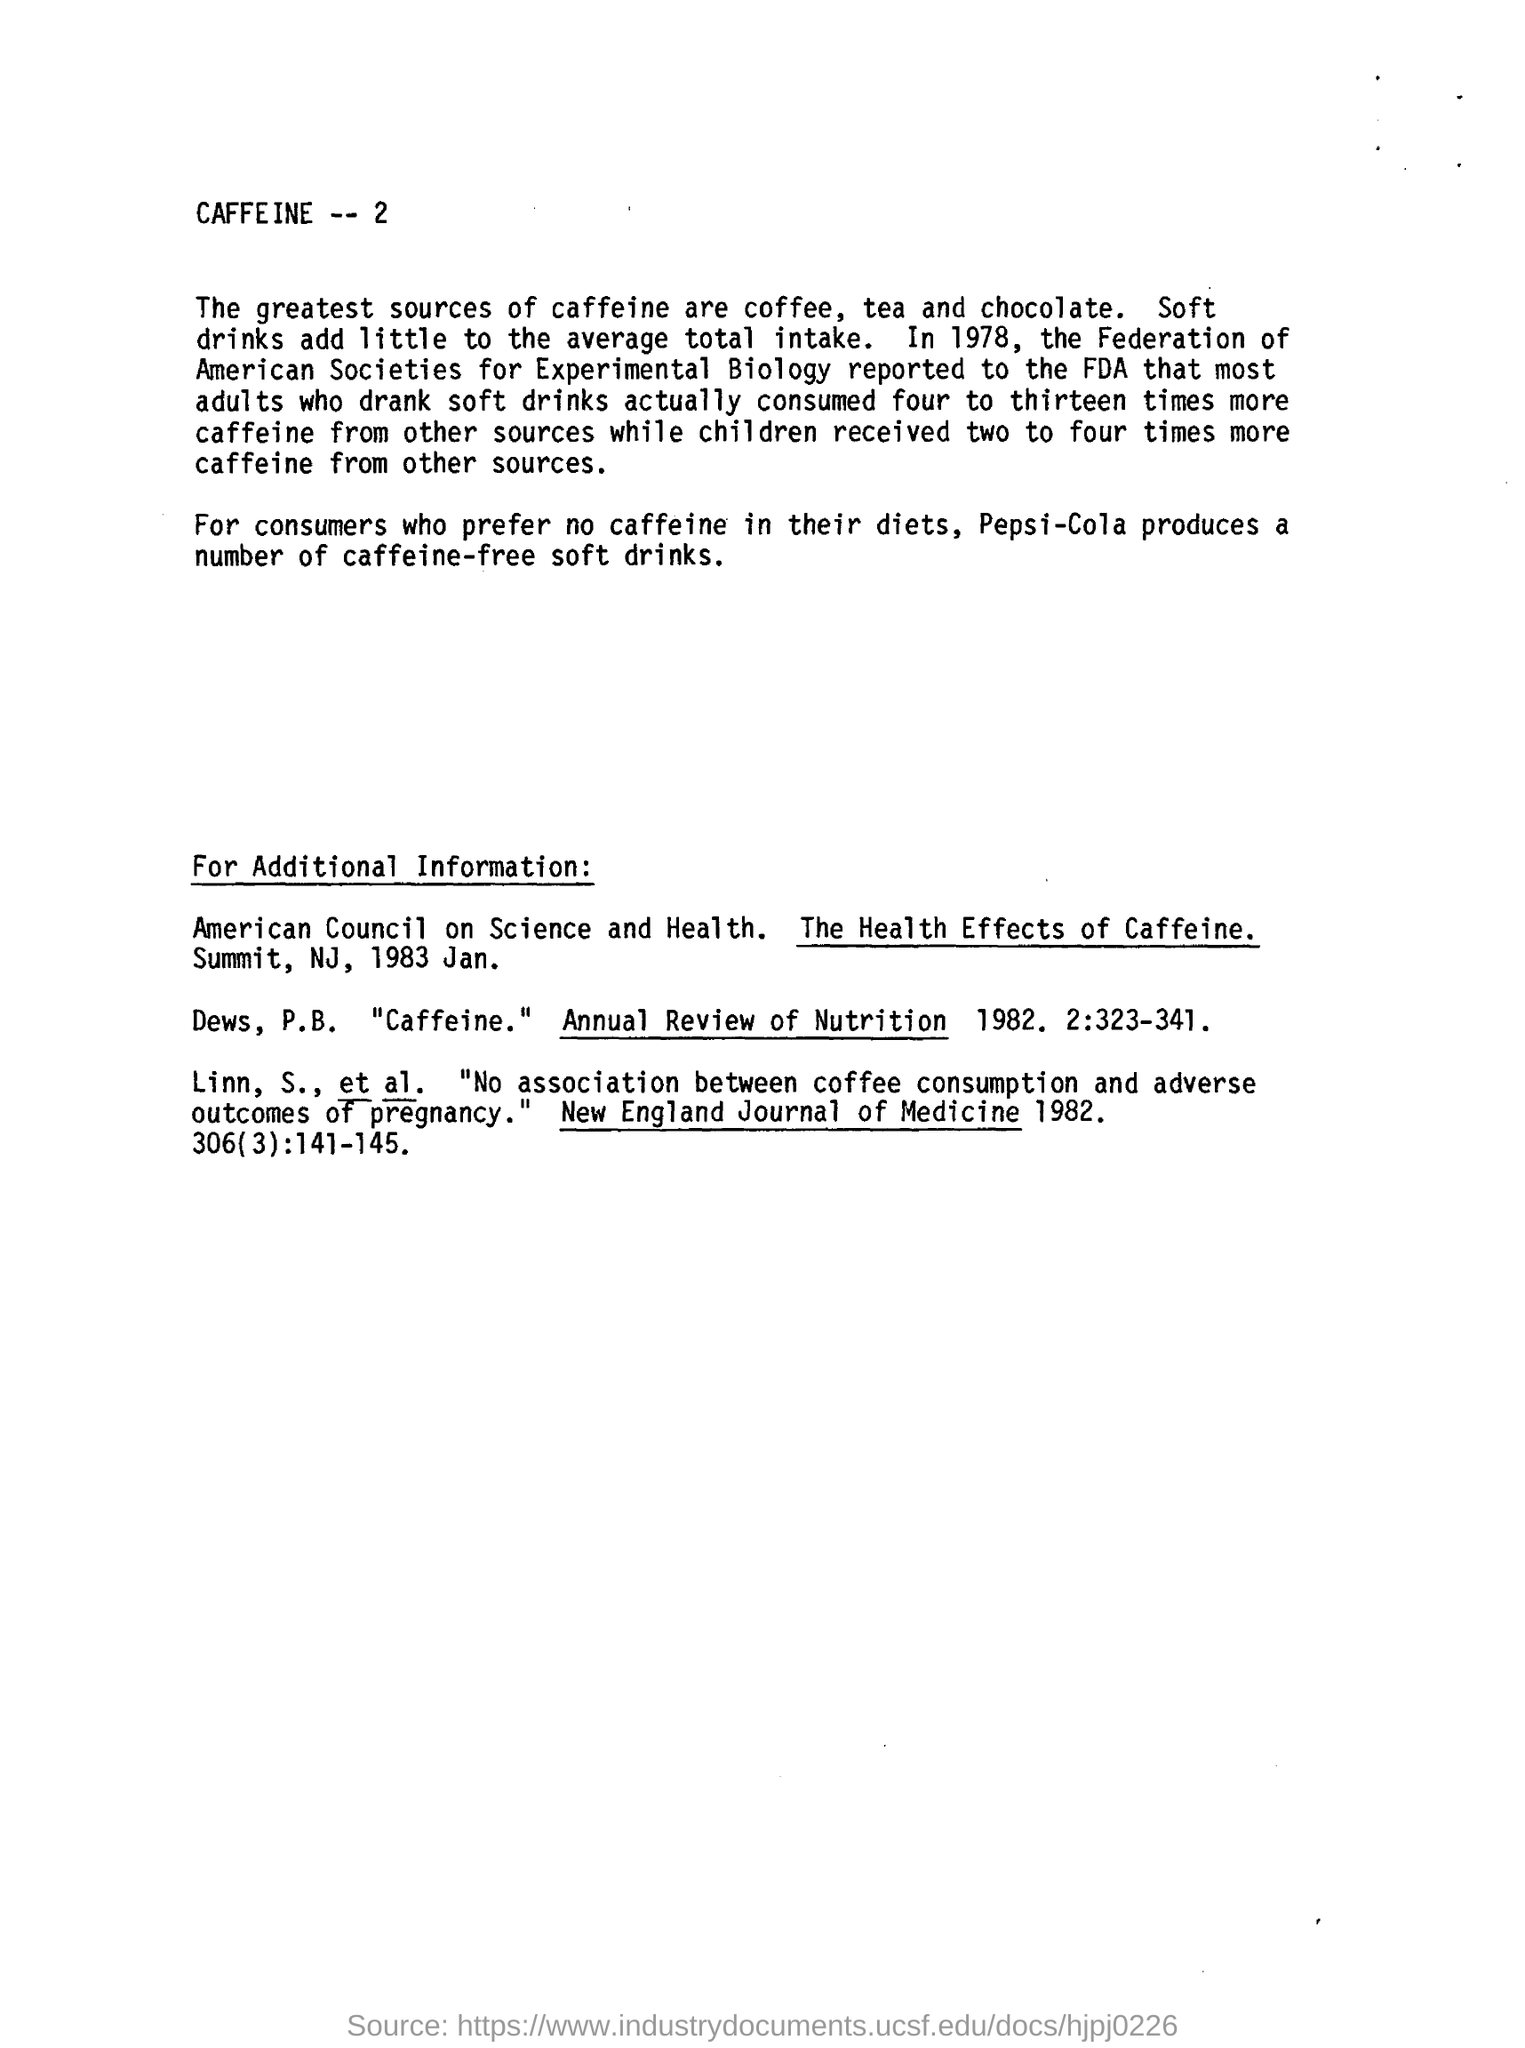Given the data from 1978, has there been a change in caffeine consumption trends in recent years? While the document cites data from 1978, caffeine consumption trends have evolved over the years due to the increasing variety of caffeinated products and changing consumer preferences. Recent trends show an increased interest in energy drinks and specialty coffee, although health-conscious consumers have also driven the market for decaffeinated options. Moreover, the proliferation of information on the internet has made individuals more aware of their caffeine intake and its potential effects on health. 